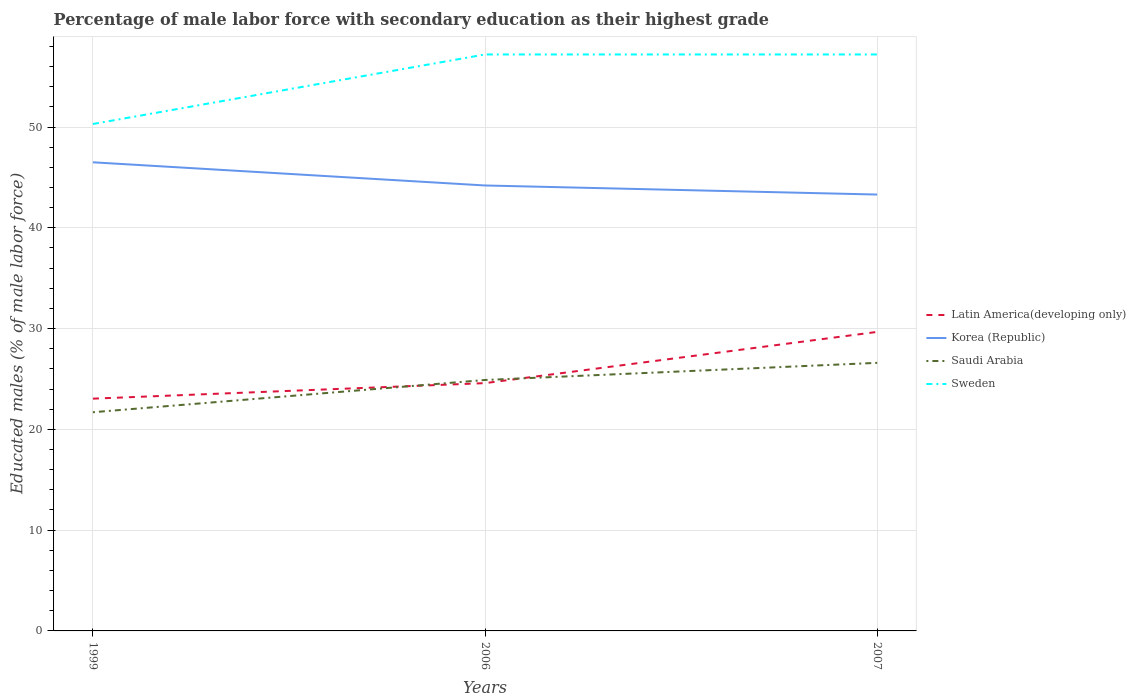How many different coloured lines are there?
Your response must be concise. 4. Does the line corresponding to Saudi Arabia intersect with the line corresponding to Sweden?
Keep it short and to the point. No. Is the number of lines equal to the number of legend labels?
Your answer should be compact. Yes. Across all years, what is the maximum percentage of male labor force with secondary education in Sweden?
Offer a very short reply. 50.3. What is the total percentage of male labor force with secondary education in Korea (Republic) in the graph?
Offer a very short reply. 0.9. What is the difference between the highest and the second highest percentage of male labor force with secondary education in Latin America(developing only)?
Keep it short and to the point. 6.62. What is the difference between the highest and the lowest percentage of male labor force with secondary education in Sweden?
Make the answer very short. 2. How many lines are there?
Offer a very short reply. 4. What is the difference between two consecutive major ticks on the Y-axis?
Provide a short and direct response. 10. How are the legend labels stacked?
Your answer should be compact. Vertical. What is the title of the graph?
Your response must be concise. Percentage of male labor force with secondary education as their highest grade. Does "Fragile and conflict affected situations" appear as one of the legend labels in the graph?
Give a very brief answer. No. What is the label or title of the X-axis?
Ensure brevity in your answer.  Years. What is the label or title of the Y-axis?
Your response must be concise. Educated males (% of male labor force). What is the Educated males (% of male labor force) of Latin America(developing only) in 1999?
Keep it short and to the point. 23.05. What is the Educated males (% of male labor force) in Korea (Republic) in 1999?
Your answer should be compact. 46.5. What is the Educated males (% of male labor force) in Saudi Arabia in 1999?
Your answer should be very brief. 21.7. What is the Educated males (% of male labor force) of Sweden in 1999?
Offer a very short reply. 50.3. What is the Educated males (% of male labor force) of Latin America(developing only) in 2006?
Your response must be concise. 24.59. What is the Educated males (% of male labor force) in Korea (Republic) in 2006?
Make the answer very short. 44.2. What is the Educated males (% of male labor force) in Saudi Arabia in 2006?
Your answer should be very brief. 24.9. What is the Educated males (% of male labor force) in Sweden in 2006?
Offer a very short reply. 57.2. What is the Educated males (% of male labor force) in Latin America(developing only) in 2007?
Make the answer very short. 29.67. What is the Educated males (% of male labor force) of Korea (Republic) in 2007?
Ensure brevity in your answer.  43.3. What is the Educated males (% of male labor force) in Saudi Arabia in 2007?
Your answer should be compact. 26.6. What is the Educated males (% of male labor force) of Sweden in 2007?
Ensure brevity in your answer.  57.2. Across all years, what is the maximum Educated males (% of male labor force) of Latin America(developing only)?
Provide a short and direct response. 29.67. Across all years, what is the maximum Educated males (% of male labor force) in Korea (Republic)?
Provide a succinct answer. 46.5. Across all years, what is the maximum Educated males (% of male labor force) in Saudi Arabia?
Provide a succinct answer. 26.6. Across all years, what is the maximum Educated males (% of male labor force) of Sweden?
Ensure brevity in your answer.  57.2. Across all years, what is the minimum Educated males (% of male labor force) of Latin America(developing only)?
Your answer should be very brief. 23.05. Across all years, what is the minimum Educated males (% of male labor force) of Korea (Republic)?
Provide a succinct answer. 43.3. Across all years, what is the minimum Educated males (% of male labor force) in Saudi Arabia?
Offer a terse response. 21.7. Across all years, what is the minimum Educated males (% of male labor force) of Sweden?
Give a very brief answer. 50.3. What is the total Educated males (% of male labor force) of Latin America(developing only) in the graph?
Offer a very short reply. 77.31. What is the total Educated males (% of male labor force) of Korea (Republic) in the graph?
Provide a short and direct response. 134. What is the total Educated males (% of male labor force) of Saudi Arabia in the graph?
Offer a terse response. 73.2. What is the total Educated males (% of male labor force) in Sweden in the graph?
Your answer should be very brief. 164.7. What is the difference between the Educated males (% of male labor force) in Latin America(developing only) in 1999 and that in 2006?
Offer a terse response. -1.54. What is the difference between the Educated males (% of male labor force) of Saudi Arabia in 1999 and that in 2006?
Your answer should be very brief. -3.2. What is the difference between the Educated males (% of male labor force) in Sweden in 1999 and that in 2006?
Give a very brief answer. -6.9. What is the difference between the Educated males (% of male labor force) in Latin America(developing only) in 1999 and that in 2007?
Keep it short and to the point. -6.62. What is the difference between the Educated males (% of male labor force) in Korea (Republic) in 1999 and that in 2007?
Provide a succinct answer. 3.2. What is the difference between the Educated males (% of male labor force) of Latin America(developing only) in 2006 and that in 2007?
Your response must be concise. -5.08. What is the difference between the Educated males (% of male labor force) of Korea (Republic) in 2006 and that in 2007?
Your answer should be very brief. 0.9. What is the difference between the Educated males (% of male labor force) of Saudi Arabia in 2006 and that in 2007?
Make the answer very short. -1.7. What is the difference between the Educated males (% of male labor force) of Latin America(developing only) in 1999 and the Educated males (% of male labor force) of Korea (Republic) in 2006?
Your response must be concise. -21.15. What is the difference between the Educated males (% of male labor force) of Latin America(developing only) in 1999 and the Educated males (% of male labor force) of Saudi Arabia in 2006?
Your answer should be very brief. -1.85. What is the difference between the Educated males (% of male labor force) of Latin America(developing only) in 1999 and the Educated males (% of male labor force) of Sweden in 2006?
Offer a very short reply. -34.15. What is the difference between the Educated males (% of male labor force) of Korea (Republic) in 1999 and the Educated males (% of male labor force) of Saudi Arabia in 2006?
Ensure brevity in your answer.  21.6. What is the difference between the Educated males (% of male labor force) in Saudi Arabia in 1999 and the Educated males (% of male labor force) in Sweden in 2006?
Your answer should be compact. -35.5. What is the difference between the Educated males (% of male labor force) of Latin America(developing only) in 1999 and the Educated males (% of male labor force) of Korea (Republic) in 2007?
Provide a succinct answer. -20.25. What is the difference between the Educated males (% of male labor force) in Latin America(developing only) in 1999 and the Educated males (% of male labor force) in Saudi Arabia in 2007?
Keep it short and to the point. -3.55. What is the difference between the Educated males (% of male labor force) in Latin America(developing only) in 1999 and the Educated males (% of male labor force) in Sweden in 2007?
Your answer should be very brief. -34.15. What is the difference between the Educated males (% of male labor force) in Korea (Republic) in 1999 and the Educated males (% of male labor force) in Saudi Arabia in 2007?
Give a very brief answer. 19.9. What is the difference between the Educated males (% of male labor force) in Korea (Republic) in 1999 and the Educated males (% of male labor force) in Sweden in 2007?
Your answer should be compact. -10.7. What is the difference between the Educated males (% of male labor force) in Saudi Arabia in 1999 and the Educated males (% of male labor force) in Sweden in 2007?
Offer a very short reply. -35.5. What is the difference between the Educated males (% of male labor force) in Latin America(developing only) in 2006 and the Educated males (% of male labor force) in Korea (Republic) in 2007?
Give a very brief answer. -18.71. What is the difference between the Educated males (% of male labor force) in Latin America(developing only) in 2006 and the Educated males (% of male labor force) in Saudi Arabia in 2007?
Provide a succinct answer. -2.01. What is the difference between the Educated males (% of male labor force) of Latin America(developing only) in 2006 and the Educated males (% of male labor force) of Sweden in 2007?
Provide a succinct answer. -32.61. What is the difference between the Educated males (% of male labor force) in Korea (Republic) in 2006 and the Educated males (% of male labor force) in Saudi Arabia in 2007?
Your response must be concise. 17.6. What is the difference between the Educated males (% of male labor force) in Saudi Arabia in 2006 and the Educated males (% of male labor force) in Sweden in 2007?
Provide a succinct answer. -32.3. What is the average Educated males (% of male labor force) in Latin America(developing only) per year?
Ensure brevity in your answer.  25.77. What is the average Educated males (% of male labor force) of Korea (Republic) per year?
Offer a terse response. 44.67. What is the average Educated males (% of male labor force) of Saudi Arabia per year?
Give a very brief answer. 24.4. What is the average Educated males (% of male labor force) in Sweden per year?
Keep it short and to the point. 54.9. In the year 1999, what is the difference between the Educated males (% of male labor force) in Latin America(developing only) and Educated males (% of male labor force) in Korea (Republic)?
Your answer should be compact. -23.45. In the year 1999, what is the difference between the Educated males (% of male labor force) in Latin America(developing only) and Educated males (% of male labor force) in Saudi Arabia?
Your answer should be compact. 1.35. In the year 1999, what is the difference between the Educated males (% of male labor force) in Latin America(developing only) and Educated males (% of male labor force) in Sweden?
Your answer should be very brief. -27.25. In the year 1999, what is the difference between the Educated males (% of male labor force) of Korea (Republic) and Educated males (% of male labor force) of Saudi Arabia?
Provide a short and direct response. 24.8. In the year 1999, what is the difference between the Educated males (% of male labor force) of Korea (Republic) and Educated males (% of male labor force) of Sweden?
Provide a succinct answer. -3.8. In the year 1999, what is the difference between the Educated males (% of male labor force) of Saudi Arabia and Educated males (% of male labor force) of Sweden?
Offer a terse response. -28.6. In the year 2006, what is the difference between the Educated males (% of male labor force) of Latin America(developing only) and Educated males (% of male labor force) of Korea (Republic)?
Ensure brevity in your answer.  -19.61. In the year 2006, what is the difference between the Educated males (% of male labor force) of Latin America(developing only) and Educated males (% of male labor force) of Saudi Arabia?
Your response must be concise. -0.31. In the year 2006, what is the difference between the Educated males (% of male labor force) of Latin America(developing only) and Educated males (% of male labor force) of Sweden?
Your response must be concise. -32.61. In the year 2006, what is the difference between the Educated males (% of male labor force) of Korea (Republic) and Educated males (% of male labor force) of Saudi Arabia?
Give a very brief answer. 19.3. In the year 2006, what is the difference between the Educated males (% of male labor force) in Korea (Republic) and Educated males (% of male labor force) in Sweden?
Provide a short and direct response. -13. In the year 2006, what is the difference between the Educated males (% of male labor force) of Saudi Arabia and Educated males (% of male labor force) of Sweden?
Your answer should be compact. -32.3. In the year 2007, what is the difference between the Educated males (% of male labor force) in Latin America(developing only) and Educated males (% of male labor force) in Korea (Republic)?
Give a very brief answer. -13.63. In the year 2007, what is the difference between the Educated males (% of male labor force) in Latin America(developing only) and Educated males (% of male labor force) in Saudi Arabia?
Offer a terse response. 3.07. In the year 2007, what is the difference between the Educated males (% of male labor force) of Latin America(developing only) and Educated males (% of male labor force) of Sweden?
Provide a succinct answer. -27.53. In the year 2007, what is the difference between the Educated males (% of male labor force) in Korea (Republic) and Educated males (% of male labor force) in Sweden?
Keep it short and to the point. -13.9. In the year 2007, what is the difference between the Educated males (% of male labor force) of Saudi Arabia and Educated males (% of male labor force) of Sweden?
Offer a very short reply. -30.6. What is the ratio of the Educated males (% of male labor force) of Latin America(developing only) in 1999 to that in 2006?
Keep it short and to the point. 0.94. What is the ratio of the Educated males (% of male labor force) of Korea (Republic) in 1999 to that in 2006?
Provide a succinct answer. 1.05. What is the ratio of the Educated males (% of male labor force) in Saudi Arabia in 1999 to that in 2006?
Provide a succinct answer. 0.87. What is the ratio of the Educated males (% of male labor force) in Sweden in 1999 to that in 2006?
Offer a very short reply. 0.88. What is the ratio of the Educated males (% of male labor force) of Latin America(developing only) in 1999 to that in 2007?
Offer a terse response. 0.78. What is the ratio of the Educated males (% of male labor force) in Korea (Republic) in 1999 to that in 2007?
Your answer should be very brief. 1.07. What is the ratio of the Educated males (% of male labor force) of Saudi Arabia in 1999 to that in 2007?
Keep it short and to the point. 0.82. What is the ratio of the Educated males (% of male labor force) in Sweden in 1999 to that in 2007?
Your answer should be very brief. 0.88. What is the ratio of the Educated males (% of male labor force) of Latin America(developing only) in 2006 to that in 2007?
Provide a succinct answer. 0.83. What is the ratio of the Educated males (% of male labor force) of Korea (Republic) in 2006 to that in 2007?
Provide a short and direct response. 1.02. What is the ratio of the Educated males (% of male labor force) of Saudi Arabia in 2006 to that in 2007?
Your response must be concise. 0.94. What is the ratio of the Educated males (% of male labor force) of Sweden in 2006 to that in 2007?
Ensure brevity in your answer.  1. What is the difference between the highest and the second highest Educated males (% of male labor force) of Latin America(developing only)?
Offer a terse response. 5.08. What is the difference between the highest and the second highest Educated males (% of male labor force) in Korea (Republic)?
Keep it short and to the point. 2.3. What is the difference between the highest and the lowest Educated males (% of male labor force) of Latin America(developing only)?
Provide a short and direct response. 6.62. What is the difference between the highest and the lowest Educated males (% of male labor force) in Saudi Arabia?
Your answer should be very brief. 4.9. What is the difference between the highest and the lowest Educated males (% of male labor force) in Sweden?
Make the answer very short. 6.9. 